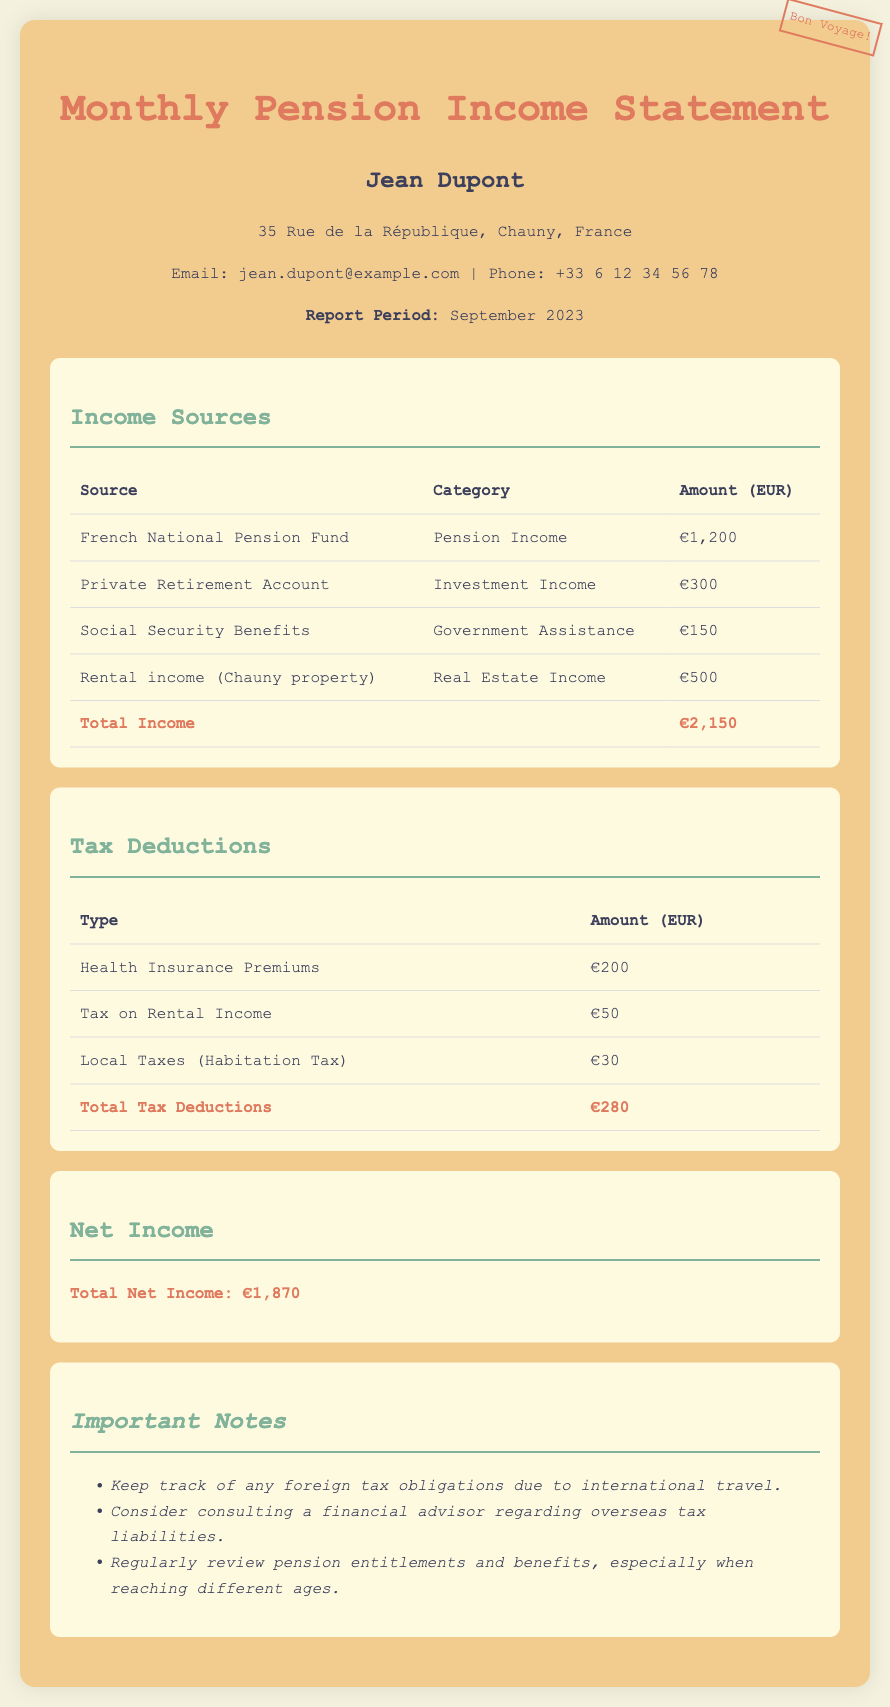What is the total income? The total income is the sum of all income sources in the document, which is €1,200 + €300 + €150 + €500 = €2,150.
Answer: €2,150 What is the amount for health insurance premiums? The health insurance premiums are listed under tax deductions, which amounts to €200.
Answer: €200 Who is the report for? The report is specifically addressed to Jean Dupont as per the header of the document.
Answer: Jean Dupont What is the net income? The net income is calculated as total income minus total tax deductions, which is €2,150 - €280 = €1,870.
Answer: €1,870 How much is the tax on rental income? The amount listed for tax on rental income, as seen under tax deductions, is €50.
Answer: €50 What type of income does the private retirement account fall under? The private retirement account is categorized under investment income in the income sources section.
Answer: Investment Income How much is the total tax deductions? The total tax deductions amount can be found by adding all deductions, resulting in €200 + €50 + €30 = €280.
Answer: €280 What is the email address provided in the document? The email address listed for Jean Dupont in the header section is jean.dupont@example.com.
Answer: jean.dupont@example.com 